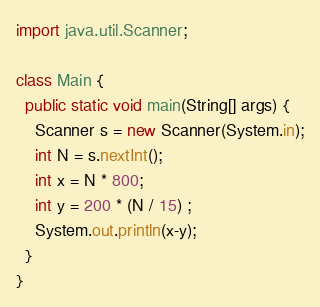<code> <loc_0><loc_0><loc_500><loc_500><_Java_>import java.util.Scanner;

class Main {
  public static void main(String[] args) {
    Scanner s = new Scanner(System.in);
    int N = s.nextInt();
    int x = N * 800;
    int y = 200 * (N / 15) ;
    System.out.println(x-y);
  }
}
</code> 